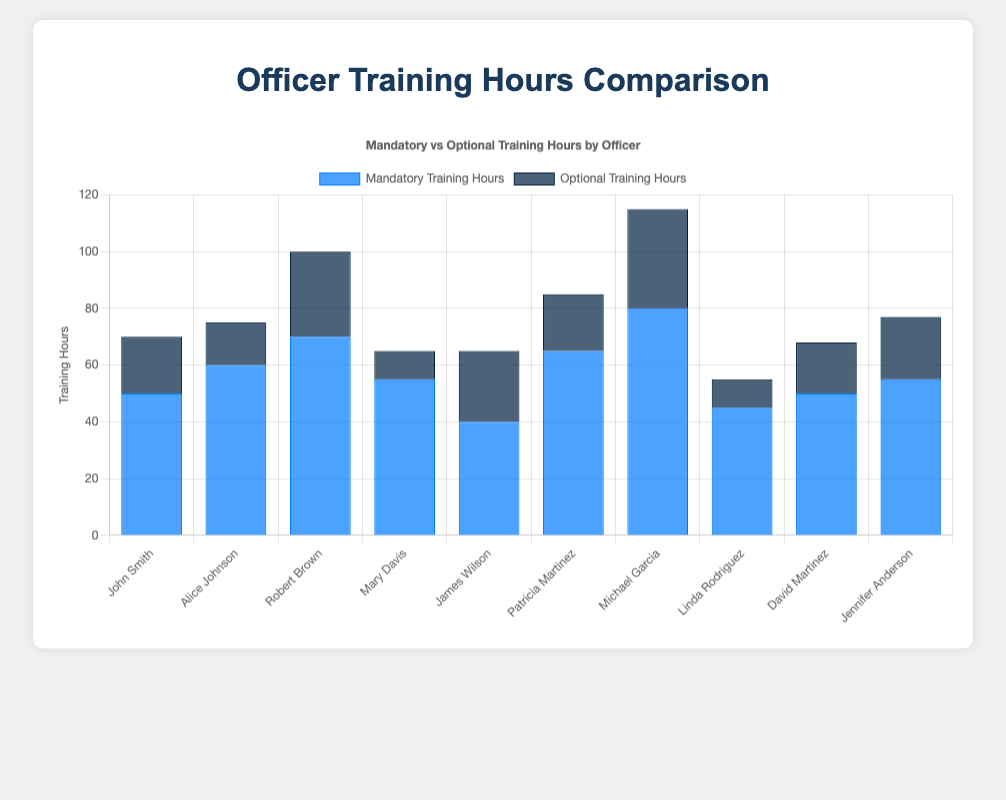Which officer completed the highest number of mandatory training hours? Michael Garcia completed 80 mandatory training hours, which is the highest among all officers.
Answer: Michael Garcia Which officer completed the fewest optional training hours? Linda Rodriguez completed only 10 optional training hours, which is the fewest among all officers.
Answer: Linda Rodriguez What is the total number of training hours (mandatory and optional) completed by Alice Johnson? Adding Alice Johnson's mandatory training hours (60) and optional training hours (15) gives 60 + 15 = 75.
Answer: 75 Who has more total training hours, John Smith or David Martinez? John Smith has 50 mandatory and 20 optional training hours, totaling 70. David Martinez has 50 mandatory and 18 optional training hours, totaling 68. Hence, John Smith has more total training hours.
Answer: John Smith How many officers have completed more than 65 mandatory training hours? Robert Brown (70), Patricia Martinez (65), and Michael Garcia (80) have completed more than 65 mandatory training hours.
Answer: 3 What is the average number of total training hours per officer? Total mandatory + optional training hours for all officers is 590 + 205 = 795. Dividing by 10 officers results in an average of 79.5 total training hours per officer.
Answer: 79.5 Which dataset (mandatory or optional) generally has taller bars? The mandatory training hours dataset generally has taller (higher) bars compared to the optional training hours dataset.
Answer: Mandatory training hours What is the difference in total training hours between Robert Brown and Mary Davis? Robert Brown has 70 mandatory and 30 optional training hours (total 100). Mary Davis has 55 mandatory and 10 optional training hours (total 65). The difference is 100 - 65 = 35 hours.
Answer: 35 Which officer has the largest difference between their mandatory and optional training hours? Michael Garcia has 80 mandatory and 35 optional training hours. The difference is 80 - 35 = 45 hours, which is the largest difference.
Answer: Michael Garcia Who completed the most optional training hours? Michael Garcia completed 35 optional training hours, which is the most among all officers.
Answer: Michael Garcia 